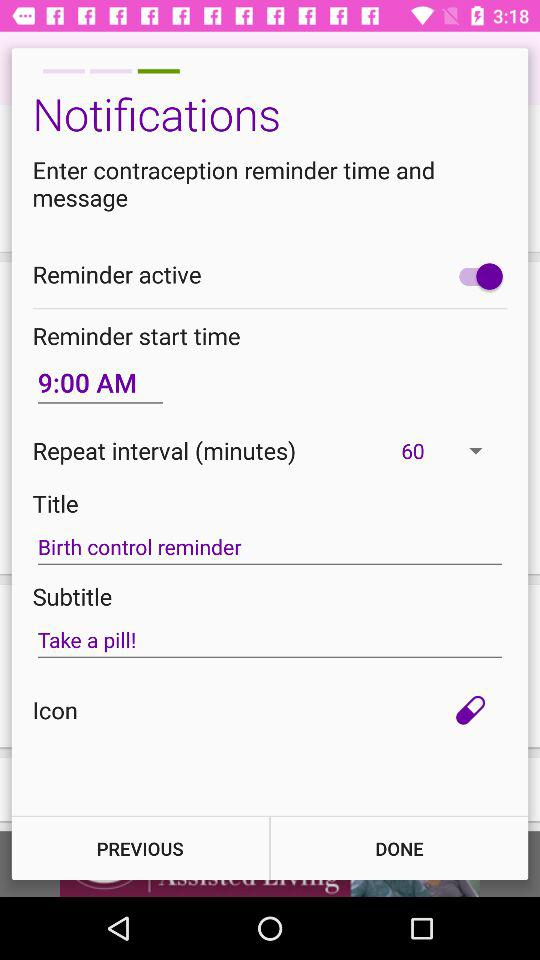What is written in the subtitle text? The phrase written in the subtitle text is "Take a pill!". 